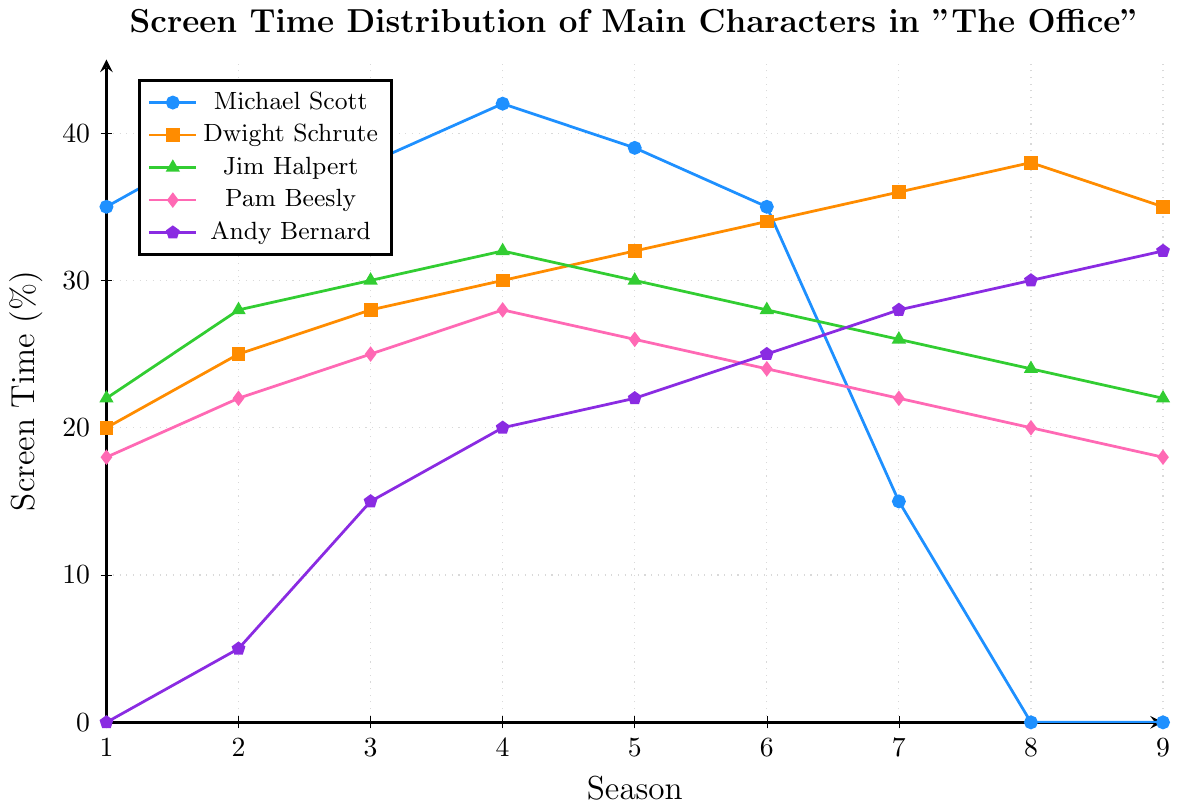Who has the highest screen time in Season 4? In the plot, the line for Michael Scott reaches the highest point at Season 4.
Answer: Michael Scott Between Season 5 and Season 7, which character shows the greatest increase in screen time? From the plot, Andy Bernard's line shows the greatest increase from 22% in Season 5 to 28% in Season 7, which is a 6% increase.
Answer: Andy Bernard When does Dwight Schrute surpass Jim Halpert in screen time? By examining the lines, Dwight Schrute surpasses Jim Halpert starting in Season 6 and continues to stay above after that.
Answer: Season 6 What is the total screen time for Pam Beesly across all seasons? Adding the screen times for Pam Beesly from each season: 18 + 22 + 25 + 28 + 26 + 24 + 22 + 20 + 18 = 203%.
Answer: 203% Which character has a constant decrease or increase in screen time over the seasons? The line for Michael Scott shows a constant screen time increase until Season 4 and then a constant decrease until Season 7 where his character leaves.
Answer: Michael Scott Compare the screen time between Andy Bernard and Pam Beesly in Season 9, who's higher? In Season 9, Andy Bernard has 32% screen time whereas Pam Beesly has 18%. Thus, Andy Bernard has higher screen time.
Answer: Andy Bernard What is the average screen time for Jim Halpert over all seasons? Adding up the screen times for Jim Halpert and then dividing by the number of seasons: (22 + 28 + 30 + 32 + 30 + 28 + 26 + 24 + 22) / 9 = 242 / 9 = ~26.89%.
Answer: ~26.89% During which season did Pam Beesly have the highest screen time? From the plot, Pam Beesly has her highest screen time during Season 4.
Answer: Season 4 How does Andy Bernard's screen time in Season 6 compare to his screen time in Season 3? In Season 6, Andy Bernard's screen time is 25%, while in Season 3, it's 15%. Therefore, in Season 6, it is higher by 10%.
Answer: Higher by 10% Which two characters have the closest screen time in Season 2? By examining the plot, Pam Beesly (22%) and Jim Halpert (28%) have the closest screen times in Season 2 among the main characters, with a difference of 6%.
Answer: Pam Beesly and Jim Halpert 